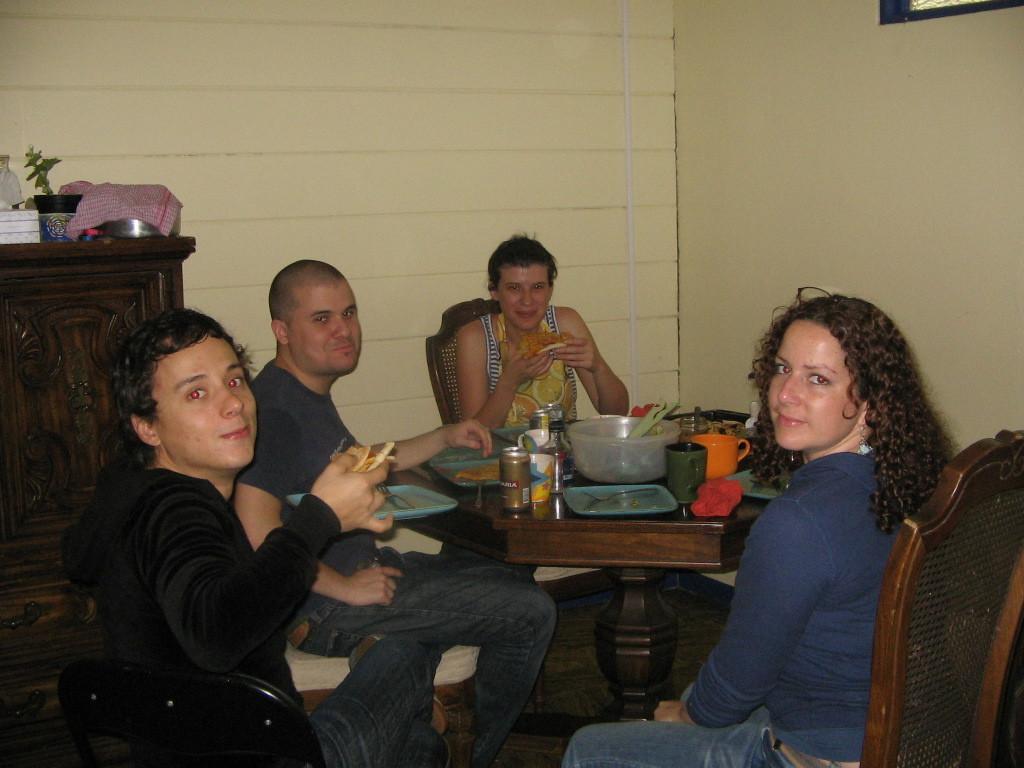Please provide a concise description of this image. In this image I can see few persons are sitting on chairs around the table. I can see two of them are holding something in their hands. In the background I can see the wooden cabinet with some objects on it and the cream colored wall. 